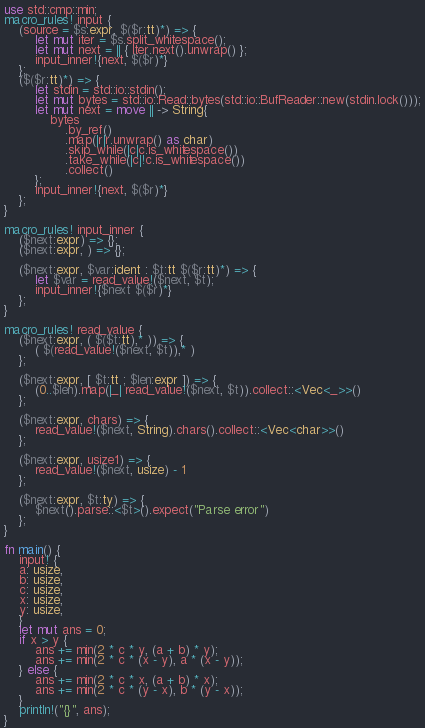<code> <loc_0><loc_0><loc_500><loc_500><_Rust_>use std::cmp::min;
macro_rules! input {
    (source = $s:expr, $($r:tt)*) => {
        let mut iter = $s.split_whitespace();
        let mut next = || { iter.next().unwrap() };
        input_inner!{next, $($r)*}
    };
    ($($r:tt)*) => {
        let stdin = std::io::stdin();
        let mut bytes = std::io::Read::bytes(std::io::BufReader::new(stdin.lock()));
        let mut next = move || -> String{
            bytes
                .by_ref()
                .map(|r|r.unwrap() as char)
                .skip_while(|c|c.is_whitespace())
                .take_while(|c|!c.is_whitespace())
                .collect()
        };
        input_inner!{next, $($r)*}
    };
}

macro_rules! input_inner {
    ($next:expr) => {};
    ($next:expr, ) => {};

    ($next:expr, $var:ident : $t:tt $($r:tt)*) => {
        let $var = read_value!($next, $t);
        input_inner!{$next $($r)*}
    };
}

macro_rules! read_value {
    ($next:expr, ( $($t:tt),* )) => {
        ( $(read_value!($next, $t)),* )
    };

    ($next:expr, [ $t:tt ; $len:expr ]) => {
        (0..$len).map(|_| read_value!($next, $t)).collect::<Vec<_>>()
    };

    ($next:expr, chars) => {
        read_value!($next, String).chars().collect::<Vec<char>>()
    };

    ($next:expr, usize1) => {
        read_value!($next, usize) - 1
    };

    ($next:expr, $t:ty) => {
        $next().parse::<$t>().expect("Parse error")
    };
}

fn main() {
    input! {
    a: usize,
    b: usize,
    c: usize,
    x: usize,
    y: usize,
    }
    let mut ans = 0;
    if x > y {
        ans += min(2 * c * y, (a + b) * y);
        ans += min(2 * c * (x - y), a * (x - y));
    } else {
        ans += min(2 * c * x, (a + b) * x);
        ans += min(2 * c * (y - x), b * (y - x));
    }
    println!("{}", ans);
}
</code> 